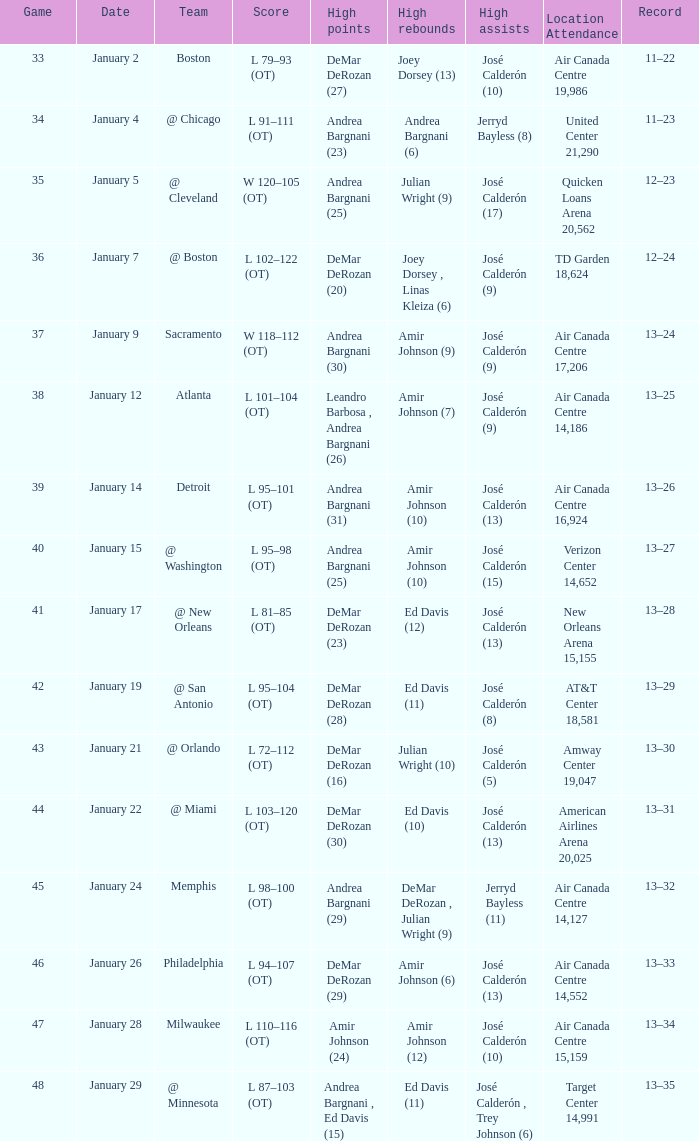Name the team for january 17 @ New Orleans. 